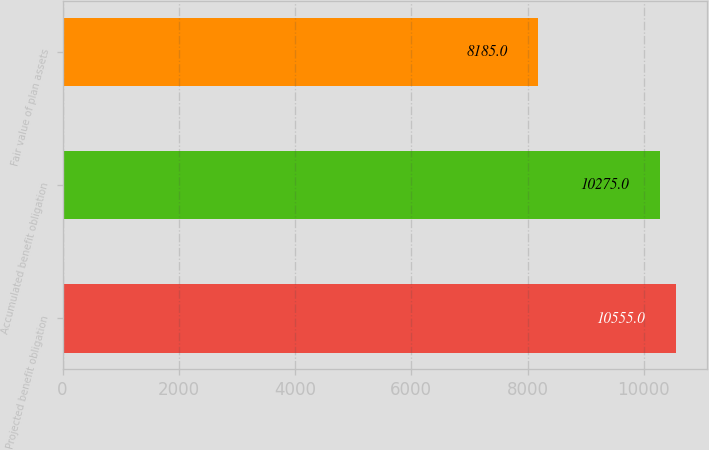Convert chart. <chart><loc_0><loc_0><loc_500><loc_500><bar_chart><fcel>Projected benefit obligation<fcel>Accumulated benefit obligation<fcel>Fair value of plan assets<nl><fcel>10555<fcel>10275<fcel>8185<nl></chart> 